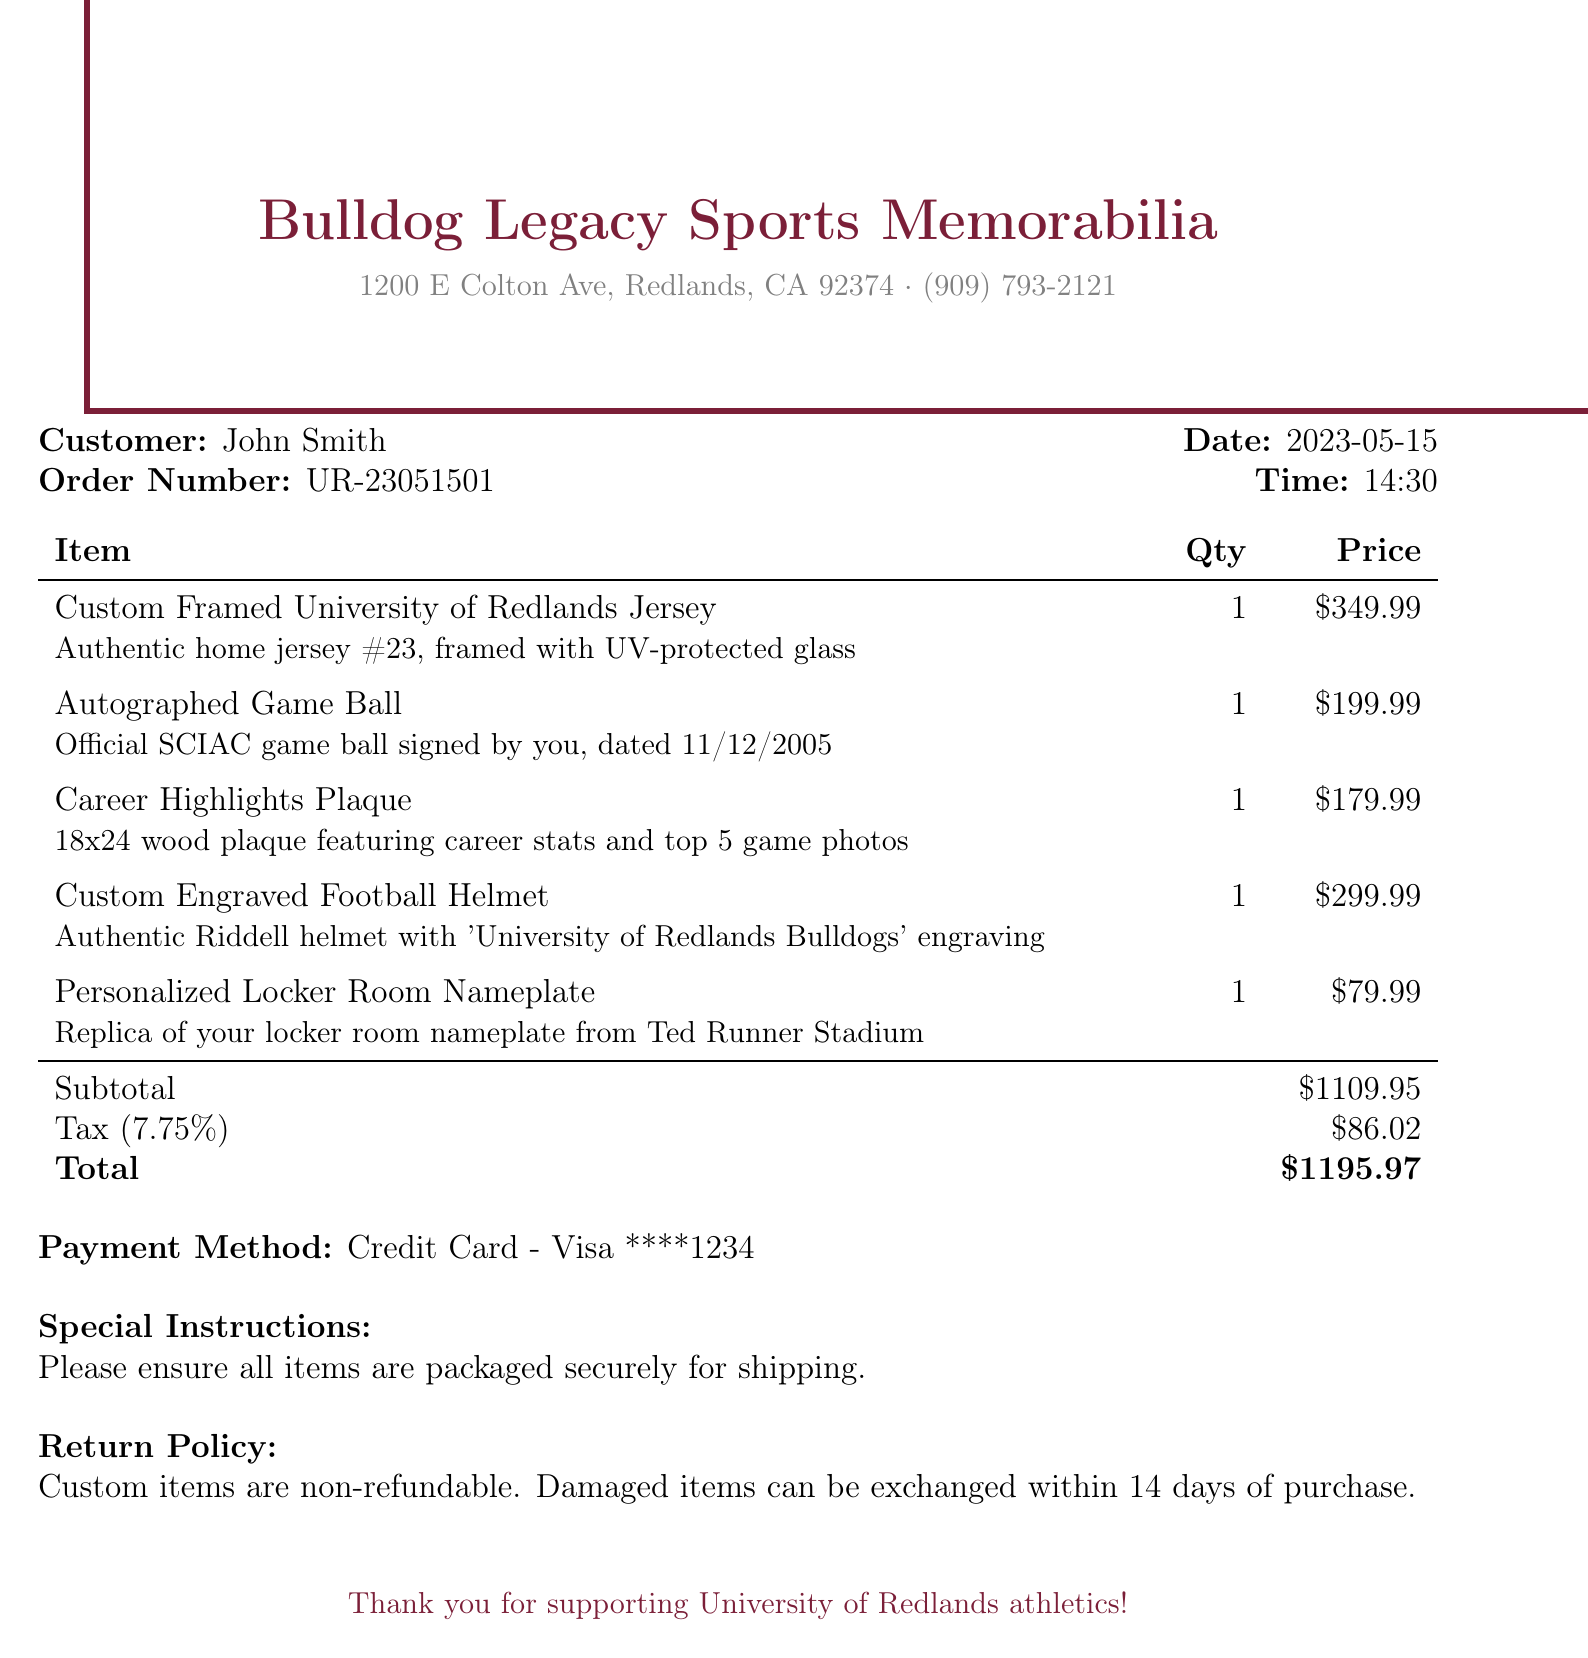what is the store name? The store name is prominently displayed at the top of the document as the title.
Answer: Bulldog Legacy Sports Memorabilia who is the customer? The customer's name is mentioned in the document under the customer details section.
Answer: John Smith what is the date of purchase? The date of the purchase is indicated in the document, showing when the transaction occurred.
Answer: 2023-05-15 what is the total amount charged? The total amount is calculated and listed at the end of the itemized section with tax included.
Answer: $1195.97 how many items were purchased? The total number of items can be counted by looking at the list of items in the document.
Answer: 5 what is the price of the custom framed jersey? The price is directly mentioned in the itemized list corresponding to the custom framed jersey.
Answer: $349.99 what is the tax rate applied? The tax rate is presented in the document as a percentage, affecting the total cost.
Answer: 7.75% what is the payment method used? The payment method is described near the bottom of the document under payment details.
Answer: Credit Card - Visa ****1234 what is the special instruction noted in the document? The special instructions provide guidance regarding the handling of the order, listed prominently before the return policy.
Answer: Please ensure all items are packaged securely for shipping what is the return policy for custom items? The return policy specifies the conditions under which items can be returned or exchanged.
Answer: Custom items are non-refundable. Damaged items can be exchanged within 14 days of purchase 